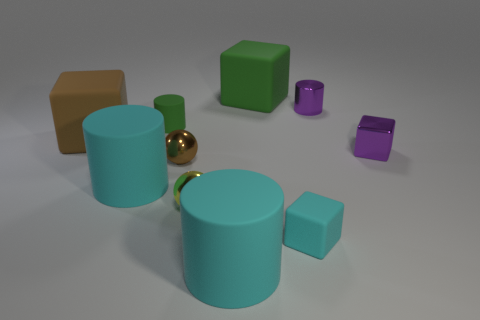There is a matte cylinder in front of the small cyan matte block; does it have the same color as the big matte cube that is in front of the green rubber cylinder?
Offer a very short reply. No. Are there any cyan cubes that have the same size as the yellow shiny object?
Your answer should be compact. Yes. What is the material of the small object that is right of the tiny cyan cube and behind the tiny metallic block?
Offer a very short reply. Metal. How many matte things are large cyan cylinders or brown objects?
Offer a very short reply. 3. The tiny green object that is the same material as the small cyan thing is what shape?
Your answer should be very brief. Cylinder. How many metal objects are both on the left side of the yellow object and behind the brown ball?
Make the answer very short. 0. There is a cube in front of the yellow thing; what is its size?
Your response must be concise. Small. How many other objects are the same color as the small matte block?
Offer a very short reply. 2. There is a large cube that is to the left of the large cyan rubber cylinder that is to the left of the small brown ball; what is its material?
Offer a very short reply. Rubber. There is a tiny cylinder that is to the left of the small brown metal thing; does it have the same color as the metallic cylinder?
Offer a terse response. No. 